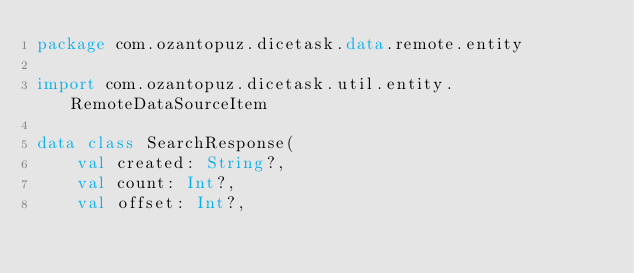<code> <loc_0><loc_0><loc_500><loc_500><_Kotlin_>package com.ozantopuz.dicetask.data.remote.entity

import com.ozantopuz.dicetask.util.entity.RemoteDataSourceItem

data class SearchResponse(
    val created: String?,
    val count: Int?,
    val offset: Int?,</code> 